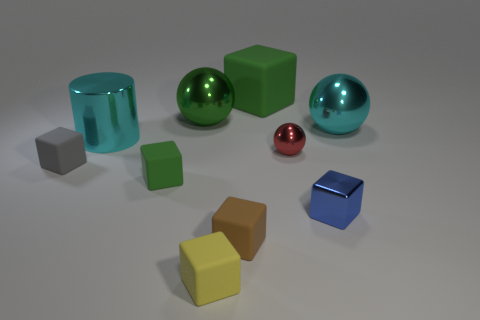Subtract all big spheres. How many spheres are left? 1 Subtract all brown blocks. How many blocks are left? 5 Subtract all cylinders. How many objects are left? 9 Subtract 2 cubes. How many cubes are left? 4 Add 5 small blue things. How many small blue things exist? 6 Subtract 1 yellow cubes. How many objects are left? 9 Subtract all green spheres. Subtract all red cylinders. How many spheres are left? 2 Subtract all yellow spheres. How many red cylinders are left? 0 Subtract all big cyan metal cylinders. Subtract all big rubber objects. How many objects are left? 8 Add 3 cylinders. How many cylinders are left? 4 